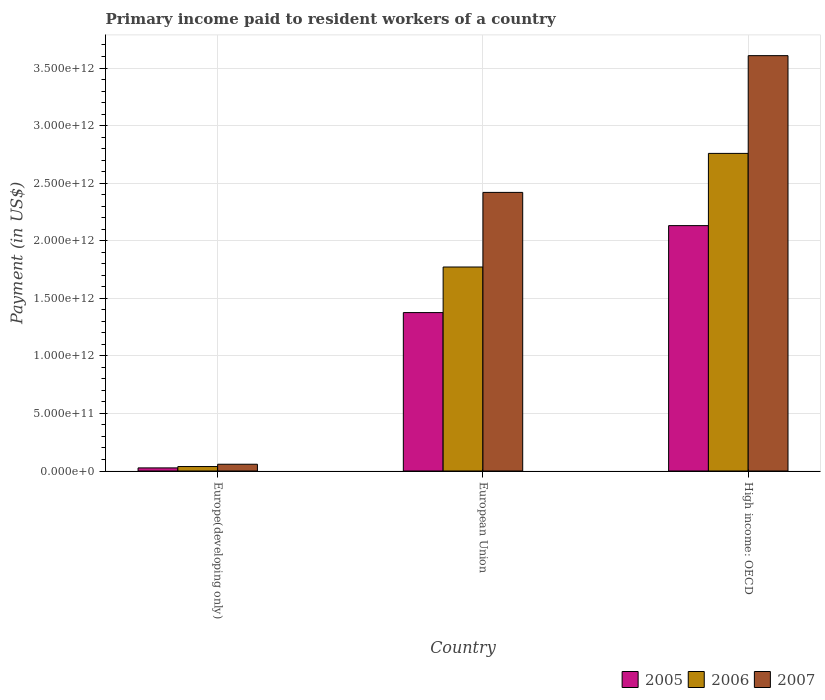How many groups of bars are there?
Offer a very short reply. 3. How many bars are there on the 3rd tick from the left?
Offer a terse response. 3. How many bars are there on the 1st tick from the right?
Your answer should be compact. 3. What is the label of the 1st group of bars from the left?
Provide a succinct answer. Europe(developing only). What is the amount paid to workers in 2006 in European Union?
Offer a terse response. 1.77e+12. Across all countries, what is the maximum amount paid to workers in 2007?
Ensure brevity in your answer.  3.61e+12. Across all countries, what is the minimum amount paid to workers in 2005?
Make the answer very short. 2.70e+1. In which country was the amount paid to workers in 2006 maximum?
Your answer should be very brief. High income: OECD. In which country was the amount paid to workers in 2006 minimum?
Your answer should be very brief. Europe(developing only). What is the total amount paid to workers in 2005 in the graph?
Your response must be concise. 3.53e+12. What is the difference between the amount paid to workers in 2007 in Europe(developing only) and that in European Union?
Provide a short and direct response. -2.36e+12. What is the difference between the amount paid to workers in 2005 in High income: OECD and the amount paid to workers in 2007 in European Union?
Your answer should be compact. -2.89e+11. What is the average amount paid to workers in 2007 per country?
Ensure brevity in your answer.  2.03e+12. What is the difference between the amount paid to workers of/in 2007 and amount paid to workers of/in 2005 in High income: OECD?
Keep it short and to the point. 1.48e+12. In how many countries, is the amount paid to workers in 2007 greater than 1600000000000 US$?
Keep it short and to the point. 2. What is the ratio of the amount paid to workers in 2007 in Europe(developing only) to that in High income: OECD?
Keep it short and to the point. 0.02. Is the amount paid to workers in 2007 in Europe(developing only) less than that in High income: OECD?
Offer a terse response. Yes. Is the difference between the amount paid to workers in 2007 in Europe(developing only) and High income: OECD greater than the difference between the amount paid to workers in 2005 in Europe(developing only) and High income: OECD?
Offer a very short reply. No. What is the difference between the highest and the second highest amount paid to workers in 2006?
Give a very brief answer. -9.87e+11. What is the difference between the highest and the lowest amount paid to workers in 2007?
Your response must be concise. 3.55e+12. What does the 2nd bar from the left in European Union represents?
Offer a terse response. 2006. Is it the case that in every country, the sum of the amount paid to workers in 2007 and amount paid to workers in 2006 is greater than the amount paid to workers in 2005?
Your answer should be compact. Yes. How many bars are there?
Provide a succinct answer. 9. Are all the bars in the graph horizontal?
Give a very brief answer. No. What is the difference between two consecutive major ticks on the Y-axis?
Your answer should be compact. 5.00e+11. Does the graph contain grids?
Provide a succinct answer. Yes. Where does the legend appear in the graph?
Your answer should be compact. Bottom right. What is the title of the graph?
Ensure brevity in your answer.  Primary income paid to resident workers of a country. What is the label or title of the Y-axis?
Offer a very short reply. Payment (in US$). What is the Payment (in US$) of 2005 in Europe(developing only)?
Offer a very short reply. 2.70e+1. What is the Payment (in US$) in 2006 in Europe(developing only)?
Make the answer very short. 3.88e+1. What is the Payment (in US$) in 2007 in Europe(developing only)?
Ensure brevity in your answer.  5.87e+1. What is the Payment (in US$) in 2005 in European Union?
Keep it short and to the point. 1.38e+12. What is the Payment (in US$) of 2006 in European Union?
Keep it short and to the point. 1.77e+12. What is the Payment (in US$) of 2007 in European Union?
Your answer should be compact. 2.42e+12. What is the Payment (in US$) in 2005 in High income: OECD?
Offer a terse response. 2.13e+12. What is the Payment (in US$) in 2006 in High income: OECD?
Offer a terse response. 2.76e+12. What is the Payment (in US$) in 2007 in High income: OECD?
Make the answer very short. 3.61e+12. Across all countries, what is the maximum Payment (in US$) in 2005?
Your answer should be very brief. 2.13e+12. Across all countries, what is the maximum Payment (in US$) of 2006?
Ensure brevity in your answer.  2.76e+12. Across all countries, what is the maximum Payment (in US$) of 2007?
Make the answer very short. 3.61e+12. Across all countries, what is the minimum Payment (in US$) of 2005?
Ensure brevity in your answer.  2.70e+1. Across all countries, what is the minimum Payment (in US$) in 2006?
Ensure brevity in your answer.  3.88e+1. Across all countries, what is the minimum Payment (in US$) of 2007?
Keep it short and to the point. 5.87e+1. What is the total Payment (in US$) in 2005 in the graph?
Offer a terse response. 3.53e+12. What is the total Payment (in US$) in 2006 in the graph?
Your response must be concise. 4.57e+12. What is the total Payment (in US$) in 2007 in the graph?
Ensure brevity in your answer.  6.09e+12. What is the difference between the Payment (in US$) of 2005 in Europe(developing only) and that in European Union?
Provide a short and direct response. -1.35e+12. What is the difference between the Payment (in US$) of 2006 in Europe(developing only) and that in European Union?
Ensure brevity in your answer.  -1.73e+12. What is the difference between the Payment (in US$) in 2007 in Europe(developing only) and that in European Union?
Ensure brevity in your answer.  -2.36e+12. What is the difference between the Payment (in US$) of 2005 in Europe(developing only) and that in High income: OECD?
Offer a very short reply. -2.10e+12. What is the difference between the Payment (in US$) in 2006 in Europe(developing only) and that in High income: OECD?
Offer a very short reply. -2.72e+12. What is the difference between the Payment (in US$) in 2007 in Europe(developing only) and that in High income: OECD?
Your answer should be very brief. -3.55e+12. What is the difference between the Payment (in US$) in 2005 in European Union and that in High income: OECD?
Provide a short and direct response. -7.55e+11. What is the difference between the Payment (in US$) of 2006 in European Union and that in High income: OECD?
Ensure brevity in your answer.  -9.87e+11. What is the difference between the Payment (in US$) of 2007 in European Union and that in High income: OECD?
Make the answer very short. -1.19e+12. What is the difference between the Payment (in US$) of 2005 in Europe(developing only) and the Payment (in US$) of 2006 in European Union?
Ensure brevity in your answer.  -1.74e+12. What is the difference between the Payment (in US$) in 2005 in Europe(developing only) and the Payment (in US$) in 2007 in European Union?
Your answer should be compact. -2.39e+12. What is the difference between the Payment (in US$) in 2006 in Europe(developing only) and the Payment (in US$) in 2007 in European Union?
Your answer should be very brief. -2.38e+12. What is the difference between the Payment (in US$) in 2005 in Europe(developing only) and the Payment (in US$) in 2006 in High income: OECD?
Offer a very short reply. -2.73e+12. What is the difference between the Payment (in US$) in 2005 in Europe(developing only) and the Payment (in US$) in 2007 in High income: OECD?
Provide a short and direct response. -3.58e+12. What is the difference between the Payment (in US$) in 2006 in Europe(developing only) and the Payment (in US$) in 2007 in High income: OECD?
Provide a succinct answer. -3.57e+12. What is the difference between the Payment (in US$) in 2005 in European Union and the Payment (in US$) in 2006 in High income: OECD?
Make the answer very short. -1.38e+12. What is the difference between the Payment (in US$) in 2005 in European Union and the Payment (in US$) in 2007 in High income: OECD?
Offer a terse response. -2.23e+12. What is the difference between the Payment (in US$) of 2006 in European Union and the Payment (in US$) of 2007 in High income: OECD?
Your answer should be compact. -1.84e+12. What is the average Payment (in US$) of 2005 per country?
Keep it short and to the point. 1.18e+12. What is the average Payment (in US$) in 2006 per country?
Keep it short and to the point. 1.52e+12. What is the average Payment (in US$) of 2007 per country?
Give a very brief answer. 2.03e+12. What is the difference between the Payment (in US$) in 2005 and Payment (in US$) in 2006 in Europe(developing only)?
Provide a succinct answer. -1.18e+1. What is the difference between the Payment (in US$) of 2005 and Payment (in US$) of 2007 in Europe(developing only)?
Make the answer very short. -3.17e+1. What is the difference between the Payment (in US$) in 2006 and Payment (in US$) in 2007 in Europe(developing only)?
Offer a terse response. -1.99e+1. What is the difference between the Payment (in US$) in 2005 and Payment (in US$) in 2006 in European Union?
Keep it short and to the point. -3.96e+11. What is the difference between the Payment (in US$) in 2005 and Payment (in US$) in 2007 in European Union?
Your answer should be very brief. -1.04e+12. What is the difference between the Payment (in US$) of 2006 and Payment (in US$) of 2007 in European Union?
Provide a short and direct response. -6.48e+11. What is the difference between the Payment (in US$) of 2005 and Payment (in US$) of 2006 in High income: OECD?
Your answer should be compact. -6.27e+11. What is the difference between the Payment (in US$) of 2005 and Payment (in US$) of 2007 in High income: OECD?
Your answer should be compact. -1.48e+12. What is the difference between the Payment (in US$) of 2006 and Payment (in US$) of 2007 in High income: OECD?
Make the answer very short. -8.49e+11. What is the ratio of the Payment (in US$) of 2005 in Europe(developing only) to that in European Union?
Ensure brevity in your answer.  0.02. What is the ratio of the Payment (in US$) in 2006 in Europe(developing only) to that in European Union?
Give a very brief answer. 0.02. What is the ratio of the Payment (in US$) of 2007 in Europe(developing only) to that in European Union?
Your response must be concise. 0.02. What is the ratio of the Payment (in US$) in 2005 in Europe(developing only) to that in High income: OECD?
Your answer should be compact. 0.01. What is the ratio of the Payment (in US$) of 2006 in Europe(developing only) to that in High income: OECD?
Provide a succinct answer. 0.01. What is the ratio of the Payment (in US$) of 2007 in Europe(developing only) to that in High income: OECD?
Offer a terse response. 0.02. What is the ratio of the Payment (in US$) in 2005 in European Union to that in High income: OECD?
Ensure brevity in your answer.  0.65. What is the ratio of the Payment (in US$) of 2006 in European Union to that in High income: OECD?
Your response must be concise. 0.64. What is the ratio of the Payment (in US$) in 2007 in European Union to that in High income: OECD?
Give a very brief answer. 0.67. What is the difference between the highest and the second highest Payment (in US$) of 2005?
Make the answer very short. 7.55e+11. What is the difference between the highest and the second highest Payment (in US$) in 2006?
Keep it short and to the point. 9.87e+11. What is the difference between the highest and the second highest Payment (in US$) in 2007?
Keep it short and to the point. 1.19e+12. What is the difference between the highest and the lowest Payment (in US$) of 2005?
Your answer should be compact. 2.10e+12. What is the difference between the highest and the lowest Payment (in US$) of 2006?
Your answer should be very brief. 2.72e+12. What is the difference between the highest and the lowest Payment (in US$) of 2007?
Your response must be concise. 3.55e+12. 